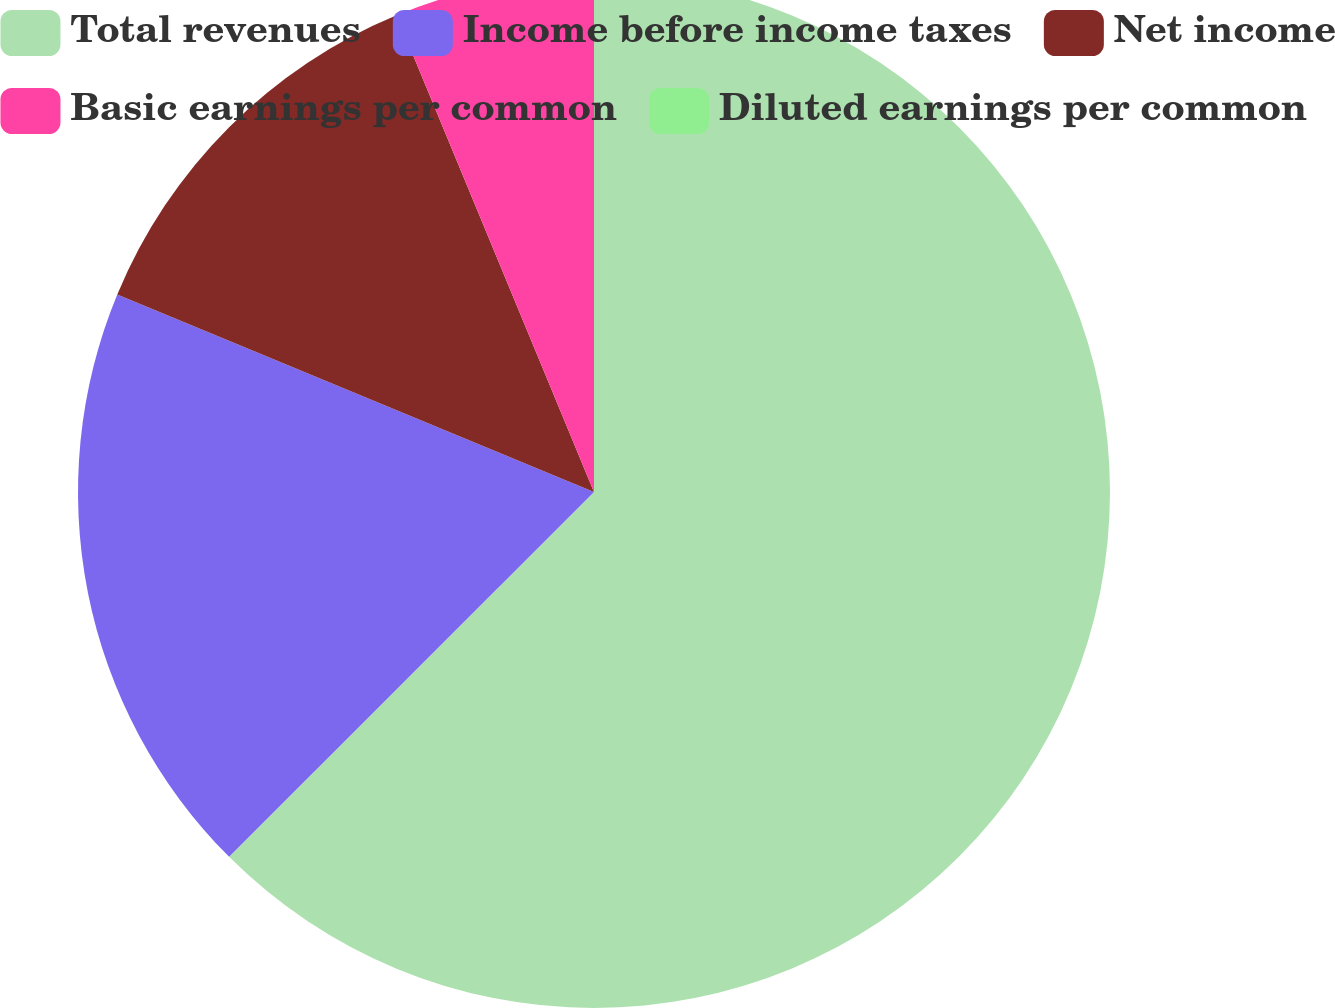Convert chart to OTSL. <chart><loc_0><loc_0><loc_500><loc_500><pie_chart><fcel>Total revenues<fcel>Income before income taxes<fcel>Net income<fcel>Basic earnings per common<fcel>Diluted earnings per common<nl><fcel>62.5%<fcel>18.75%<fcel>12.5%<fcel>6.25%<fcel>0.0%<nl></chart> 